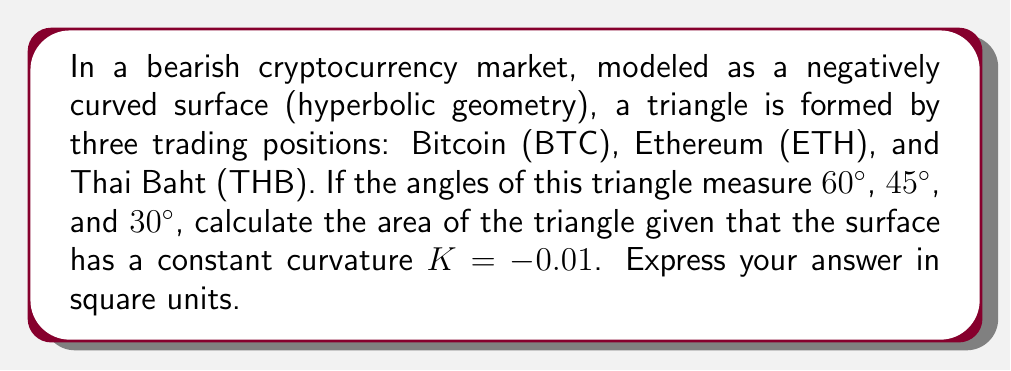Can you solve this math problem? Let's approach this step-by-step:

1) In hyperbolic geometry, the area of a triangle is given by the Gauss-Bonnet formula:

   $$A = \frac{\pi - (\alpha + \beta + \gamma)}{-K}$$

   where $A$ is the area, $K$ is the curvature, and $\alpha$, $\beta$, $\gamma$ are the angles of the triangle.

2) We're given:
   $K = -0.01$
   $\alpha = 60° = \frac{\pi}{3}$ radians
   $\beta = 45° = \frac{\pi}{4}$ radians
   $\gamma = 30° = \frac{\pi}{6}$ radians

3) Let's sum the angles:
   $$\alpha + \beta + \gamma = \frac{\pi}{3} + \frac{\pi}{4} + \frac{\pi}{6} = \frac{4\pi}{12} + \frac{3\pi}{12} + \frac{2\pi}{12} = \frac{9\pi}{12} = \frac{3\pi}{4}$$

4) Now, let's substitute into the formula:

   $$A = \frac{\pi - (\frac{3\pi}{4})}{-(-0.01)} = \frac{\frac{\pi}{4}}{0.01} = 25\pi$$

5) Therefore, the area of the triangle is $25\pi$ square units.
Answer: $25\pi$ square units 